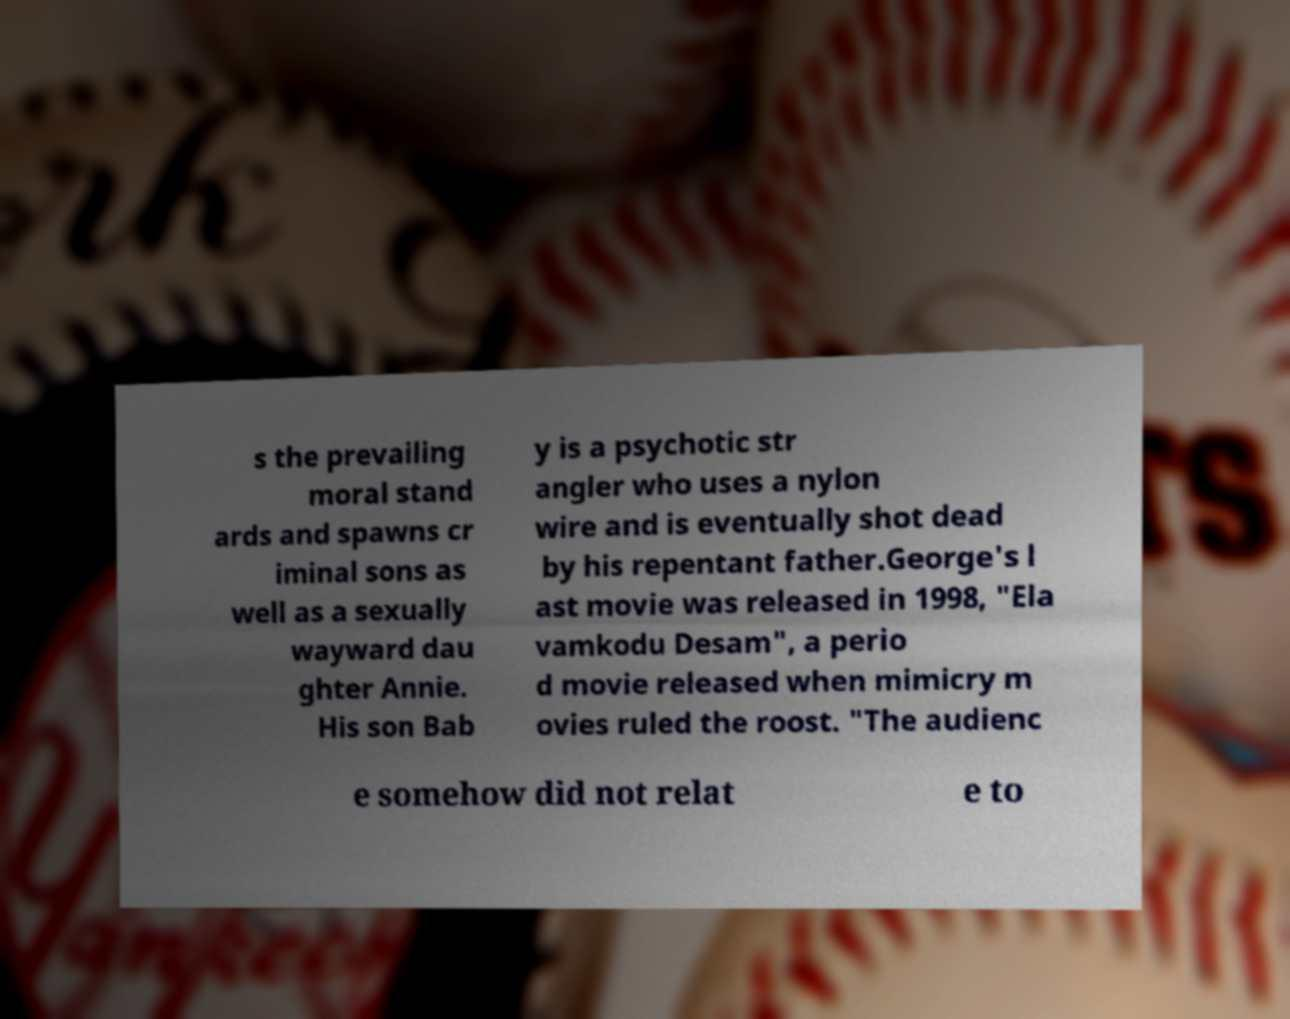Could you assist in decoding the text presented in this image and type it out clearly? s the prevailing moral stand ards and spawns cr iminal sons as well as a sexually wayward dau ghter Annie. His son Bab y is a psychotic str angler who uses a nylon wire and is eventually shot dead by his repentant father.George's l ast movie was released in 1998, "Ela vamkodu Desam", a perio d movie released when mimicry m ovies ruled the roost. "The audienc e somehow did not relat e to 